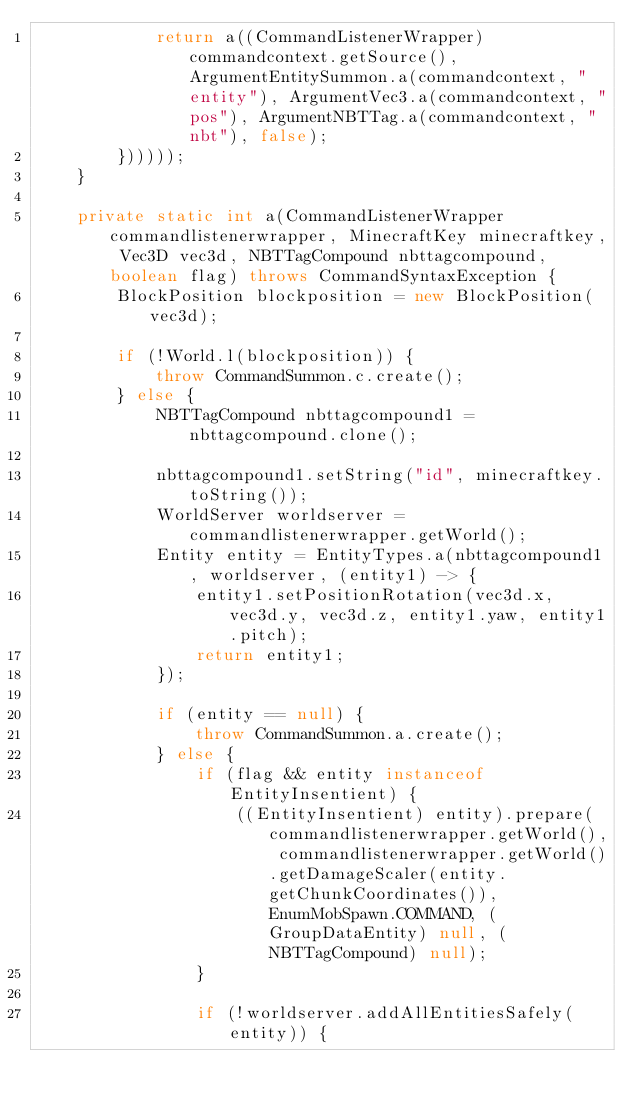Convert code to text. <code><loc_0><loc_0><loc_500><loc_500><_Java_>            return a((CommandListenerWrapper) commandcontext.getSource(), ArgumentEntitySummon.a(commandcontext, "entity"), ArgumentVec3.a(commandcontext, "pos"), ArgumentNBTTag.a(commandcontext, "nbt"), false);
        })))));
    }

    private static int a(CommandListenerWrapper commandlistenerwrapper, MinecraftKey minecraftkey, Vec3D vec3d, NBTTagCompound nbttagcompound, boolean flag) throws CommandSyntaxException {
        BlockPosition blockposition = new BlockPosition(vec3d);

        if (!World.l(blockposition)) {
            throw CommandSummon.c.create();
        } else {
            NBTTagCompound nbttagcompound1 = nbttagcompound.clone();

            nbttagcompound1.setString("id", minecraftkey.toString());
            WorldServer worldserver = commandlistenerwrapper.getWorld();
            Entity entity = EntityTypes.a(nbttagcompound1, worldserver, (entity1) -> {
                entity1.setPositionRotation(vec3d.x, vec3d.y, vec3d.z, entity1.yaw, entity1.pitch);
                return entity1;
            });

            if (entity == null) {
                throw CommandSummon.a.create();
            } else {
                if (flag && entity instanceof EntityInsentient) {
                    ((EntityInsentient) entity).prepare(commandlistenerwrapper.getWorld(), commandlistenerwrapper.getWorld().getDamageScaler(entity.getChunkCoordinates()), EnumMobSpawn.COMMAND, (GroupDataEntity) null, (NBTTagCompound) null);
                }

                if (!worldserver.addAllEntitiesSafely(entity)) {</code> 